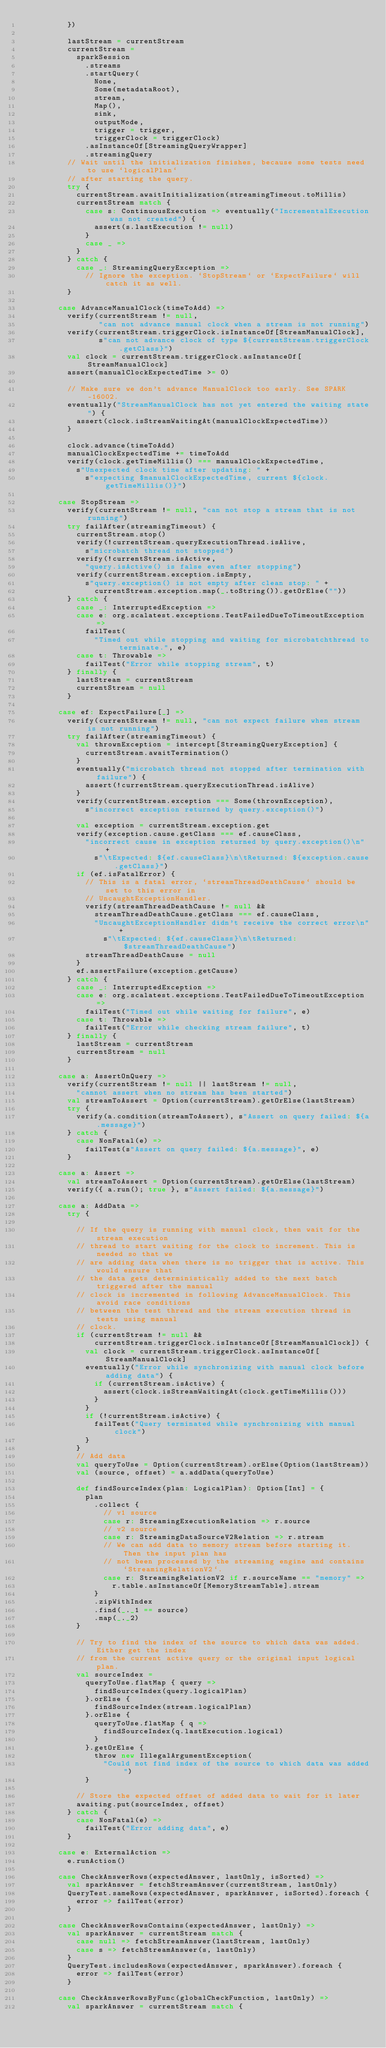<code> <loc_0><loc_0><loc_500><loc_500><_Scala_>          })

          lastStream = currentStream
          currentStream =
            sparkSession
              .streams
              .startQuery(
                None,
                Some(metadataRoot),
                stream,
                Map(),
                sink,
                outputMode,
                trigger = trigger,
                triggerClock = triggerClock)
              .asInstanceOf[StreamingQueryWrapper]
              .streamingQuery
          // Wait until the initialization finishes, because some tests need to use `logicalPlan`
          // after starting the query.
          try {
            currentStream.awaitInitialization(streamingTimeout.toMillis)
            currentStream match {
              case s: ContinuousExecution => eventually("IncrementalExecution was not created") {
                assert(s.lastExecution != null)
              }
              case _ =>
            }
          } catch {
            case _: StreamingQueryException =>
              // Ignore the exception. `StopStream` or `ExpectFailure` will catch it as well.
          }

        case AdvanceManualClock(timeToAdd) =>
          verify(currentStream != null,
                 "can not advance manual clock when a stream is not running")
          verify(currentStream.triggerClock.isInstanceOf[StreamManualClock],
                 s"can not advance clock of type ${currentStream.triggerClock.getClass}")
          val clock = currentStream.triggerClock.asInstanceOf[StreamManualClock]
          assert(manualClockExpectedTime >= 0)

          // Make sure we don't advance ManualClock too early. See SPARK-16002.
          eventually("StreamManualClock has not yet entered the waiting state") {
            assert(clock.isStreamWaitingAt(manualClockExpectedTime))
          }

          clock.advance(timeToAdd)
          manualClockExpectedTime += timeToAdd
          verify(clock.getTimeMillis() === manualClockExpectedTime,
            s"Unexpected clock time after updating: " +
              s"expecting $manualClockExpectedTime, current ${clock.getTimeMillis()}")

        case StopStream =>
          verify(currentStream != null, "can not stop a stream that is not running")
          try failAfter(streamingTimeout) {
            currentStream.stop()
            verify(!currentStream.queryExecutionThread.isAlive,
              s"microbatch thread not stopped")
            verify(!currentStream.isActive,
              "query.isActive() is false even after stopping")
            verify(currentStream.exception.isEmpty,
              s"query.exception() is not empty after clean stop: " +
                currentStream.exception.map(_.toString()).getOrElse(""))
          } catch {
            case _: InterruptedException =>
            case e: org.scalatest.exceptions.TestFailedDueToTimeoutException =>
              failTest(
                "Timed out while stopping and waiting for microbatchthread to terminate.", e)
            case t: Throwable =>
              failTest("Error while stopping stream", t)
          } finally {
            lastStream = currentStream
            currentStream = null
          }

        case ef: ExpectFailure[_] =>
          verify(currentStream != null, "can not expect failure when stream is not running")
          try failAfter(streamingTimeout) {
            val thrownException = intercept[StreamingQueryException] {
              currentStream.awaitTermination()
            }
            eventually("microbatch thread not stopped after termination with failure") {
              assert(!currentStream.queryExecutionThread.isAlive)
            }
            verify(currentStream.exception === Some(thrownException),
              s"incorrect exception returned by query.exception()")

            val exception = currentStream.exception.get
            verify(exception.cause.getClass === ef.causeClass,
              "incorrect cause in exception returned by query.exception()\n" +
                s"\tExpected: ${ef.causeClass}\n\tReturned: ${exception.cause.getClass}")
            if (ef.isFatalError) {
              // This is a fatal error, `streamThreadDeathCause` should be set to this error in
              // UncaughtExceptionHandler.
              verify(streamThreadDeathCause != null &&
                streamThreadDeathCause.getClass === ef.causeClass,
                "UncaughtExceptionHandler didn't receive the correct error\n" +
                  s"\tExpected: ${ef.causeClass}\n\tReturned: $streamThreadDeathCause")
              streamThreadDeathCause = null
            }
            ef.assertFailure(exception.getCause)
          } catch {
            case _: InterruptedException =>
            case e: org.scalatest.exceptions.TestFailedDueToTimeoutException =>
              failTest("Timed out while waiting for failure", e)
            case t: Throwable =>
              failTest("Error while checking stream failure", t)
          } finally {
            lastStream = currentStream
            currentStream = null
          }

        case a: AssertOnQuery =>
          verify(currentStream != null || lastStream != null,
            "cannot assert when no stream has been started")
          val streamToAssert = Option(currentStream).getOrElse(lastStream)
          try {
            verify(a.condition(streamToAssert), s"Assert on query failed: ${a.message}")
          } catch {
            case NonFatal(e) =>
              failTest(s"Assert on query failed: ${a.message}", e)
          }

        case a: Assert =>
          val streamToAssert = Option(currentStream).getOrElse(lastStream)
          verify({ a.run(); true }, s"Assert failed: ${a.message}")

        case a: AddData =>
          try {

            // If the query is running with manual clock, then wait for the stream execution
            // thread to start waiting for the clock to increment. This is needed so that we
            // are adding data when there is no trigger that is active. This would ensure that
            // the data gets deterministically added to the next batch triggered after the manual
            // clock is incremented in following AdvanceManualClock. This avoid race conditions
            // between the test thread and the stream execution thread in tests using manual
            // clock.
            if (currentStream != null &&
                currentStream.triggerClock.isInstanceOf[StreamManualClock]) {
              val clock = currentStream.triggerClock.asInstanceOf[StreamManualClock]
              eventually("Error while synchronizing with manual clock before adding data") {
                if (currentStream.isActive) {
                  assert(clock.isStreamWaitingAt(clock.getTimeMillis()))
                }
              }
              if (!currentStream.isActive) {
                failTest("Query terminated while synchronizing with manual clock")
              }
            }
            // Add data
            val queryToUse = Option(currentStream).orElse(Option(lastStream))
            val (source, offset) = a.addData(queryToUse)

            def findSourceIndex(plan: LogicalPlan): Option[Int] = {
              plan
                .collect {
                  // v1 source
                  case r: StreamingExecutionRelation => r.source
                  // v2 source
                  case r: StreamingDataSourceV2Relation => r.stream
                  // We can add data to memory stream before starting it. Then the input plan has
                  // not been processed by the streaming engine and contains `StreamingRelationV2`.
                  case r: StreamingRelationV2 if r.sourceName == "memory" =>
                    r.table.asInstanceOf[MemoryStreamTable].stream
                }
                .zipWithIndex
                .find(_._1 == source)
                .map(_._2)
            }

            // Try to find the index of the source to which data was added. Either get the index
            // from the current active query or the original input logical plan.
            val sourceIndex =
              queryToUse.flatMap { query =>
                findSourceIndex(query.logicalPlan)
              }.orElse {
                findSourceIndex(stream.logicalPlan)
              }.orElse {
                queryToUse.flatMap { q =>
                  findSourceIndex(q.lastExecution.logical)
                }
              }.getOrElse {
                throw new IllegalArgumentException(
                  "Could not find index of the source to which data was added")
              }

            // Store the expected offset of added data to wait for it later
            awaiting.put(sourceIndex, offset)
          } catch {
            case NonFatal(e) =>
              failTest("Error adding data", e)
          }

        case e: ExternalAction =>
          e.runAction()

        case CheckAnswerRows(expectedAnswer, lastOnly, isSorted) =>
          val sparkAnswer = fetchStreamAnswer(currentStream, lastOnly)
          QueryTest.sameRows(expectedAnswer, sparkAnswer, isSorted).foreach {
            error => failTest(error)
          }

        case CheckAnswerRowsContains(expectedAnswer, lastOnly) =>
          val sparkAnswer = currentStream match {
            case null => fetchStreamAnswer(lastStream, lastOnly)
            case s => fetchStreamAnswer(s, lastOnly)
          }
          QueryTest.includesRows(expectedAnswer, sparkAnswer).foreach {
            error => failTest(error)
          }

        case CheckAnswerRowsByFunc(globalCheckFunction, lastOnly) =>
          val sparkAnswer = currentStream match {</code> 